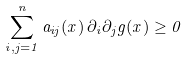Convert formula to latex. <formula><loc_0><loc_0><loc_500><loc_500>\sum _ { i , j = 1 } ^ { n } a _ { i j } ( x ) \, \partial _ { i } \partial _ { j } g ( x ) \geq 0</formula> 